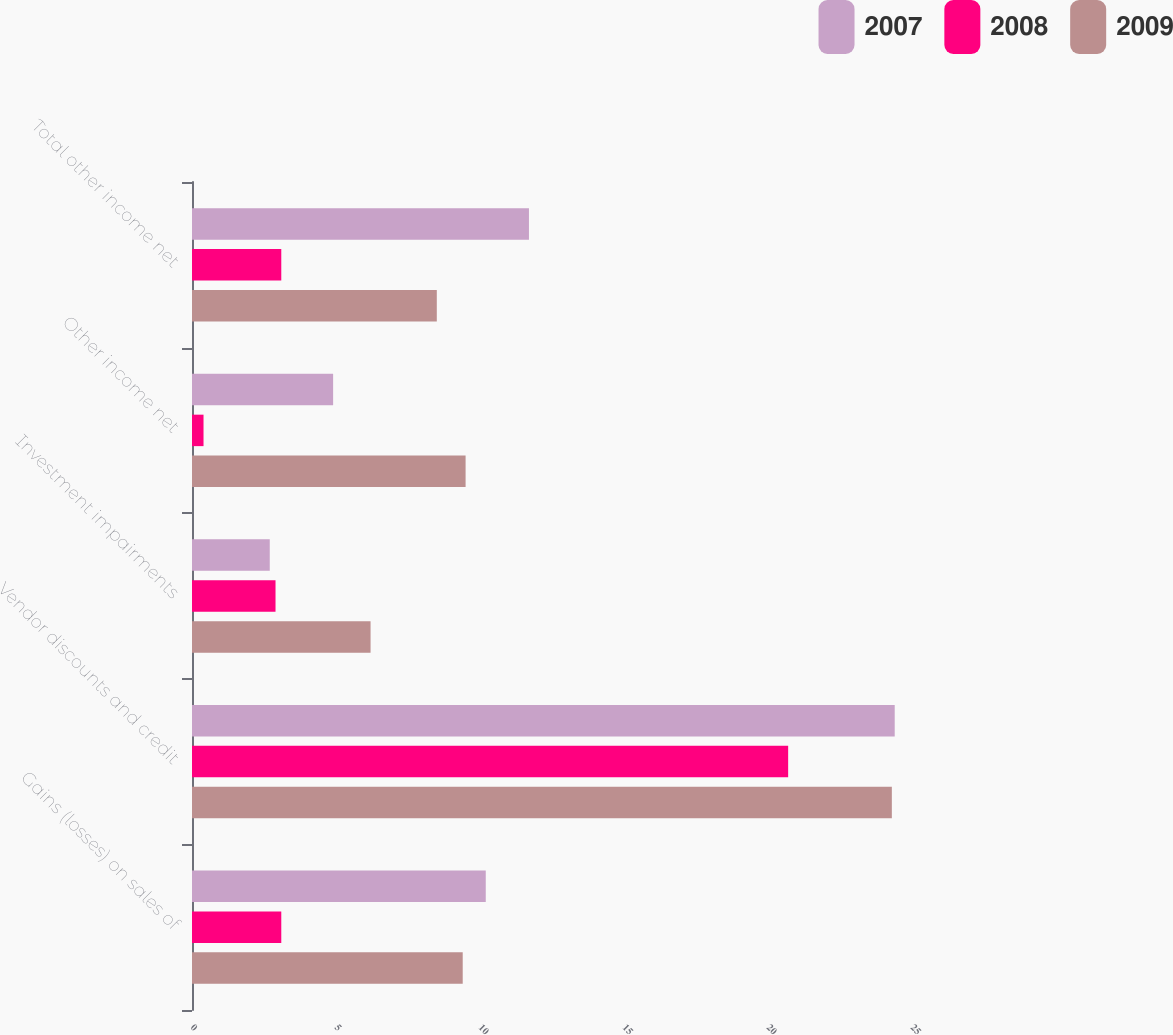Convert chart to OTSL. <chart><loc_0><loc_0><loc_500><loc_500><stacked_bar_chart><ecel><fcel>Gains (losses) on sales of<fcel>Vendor discounts and credit<fcel>Investment impairments<fcel>Other income net<fcel>Total other income net<nl><fcel>2007<fcel>10.2<fcel>24.4<fcel>2.7<fcel>4.9<fcel>11.7<nl><fcel>2008<fcel>3.1<fcel>20.7<fcel>2.9<fcel>0.4<fcel>3.1<nl><fcel>2009<fcel>9.4<fcel>24.3<fcel>6.2<fcel>9.5<fcel>8.5<nl></chart> 